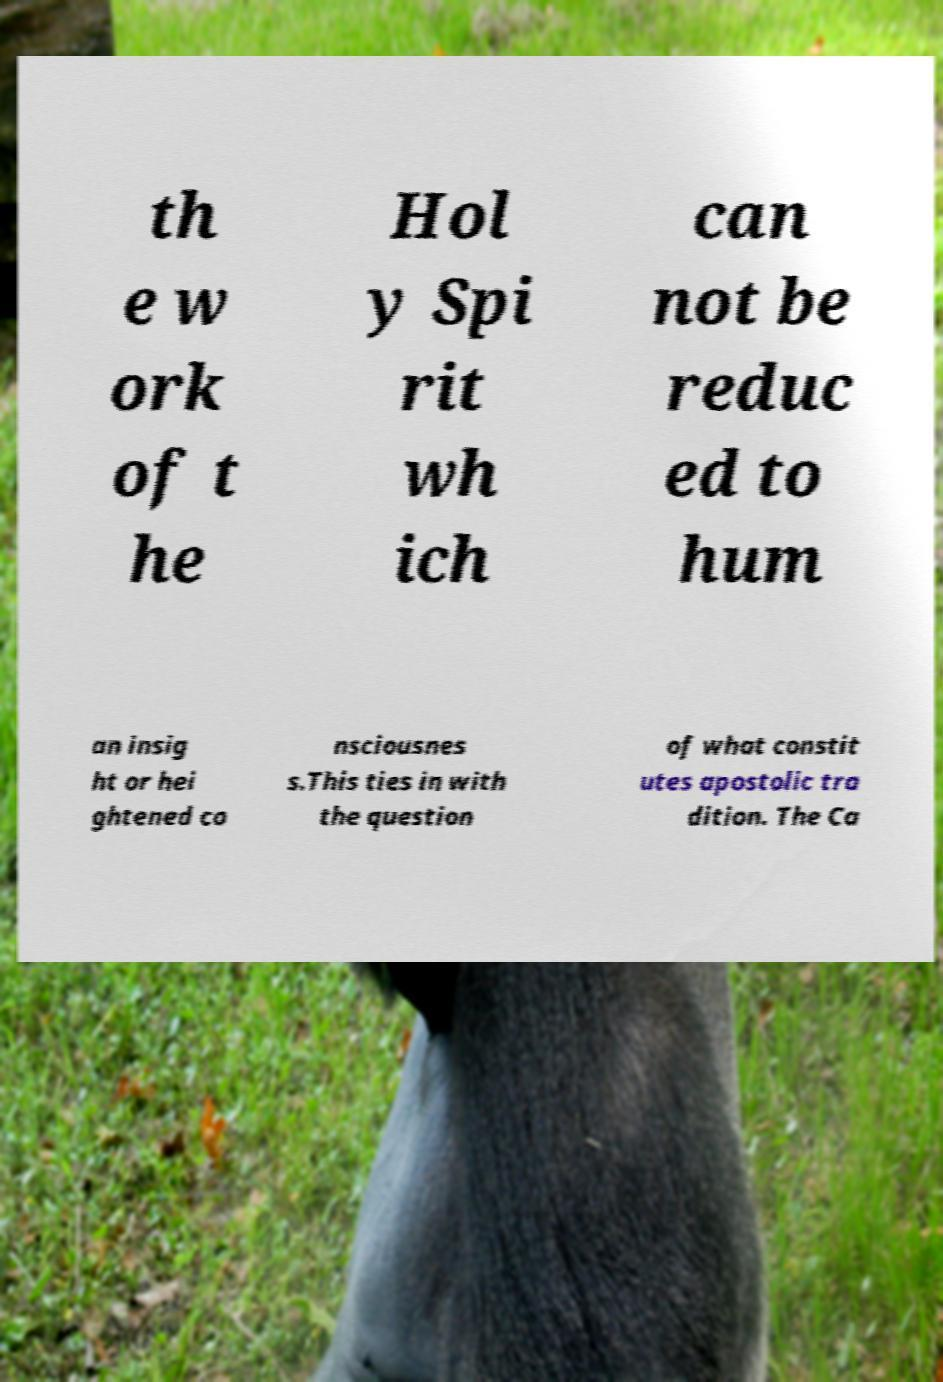I need the written content from this picture converted into text. Can you do that? th e w ork of t he Hol y Spi rit wh ich can not be reduc ed to hum an insig ht or hei ghtened co nsciousnes s.This ties in with the question of what constit utes apostolic tra dition. The Ca 